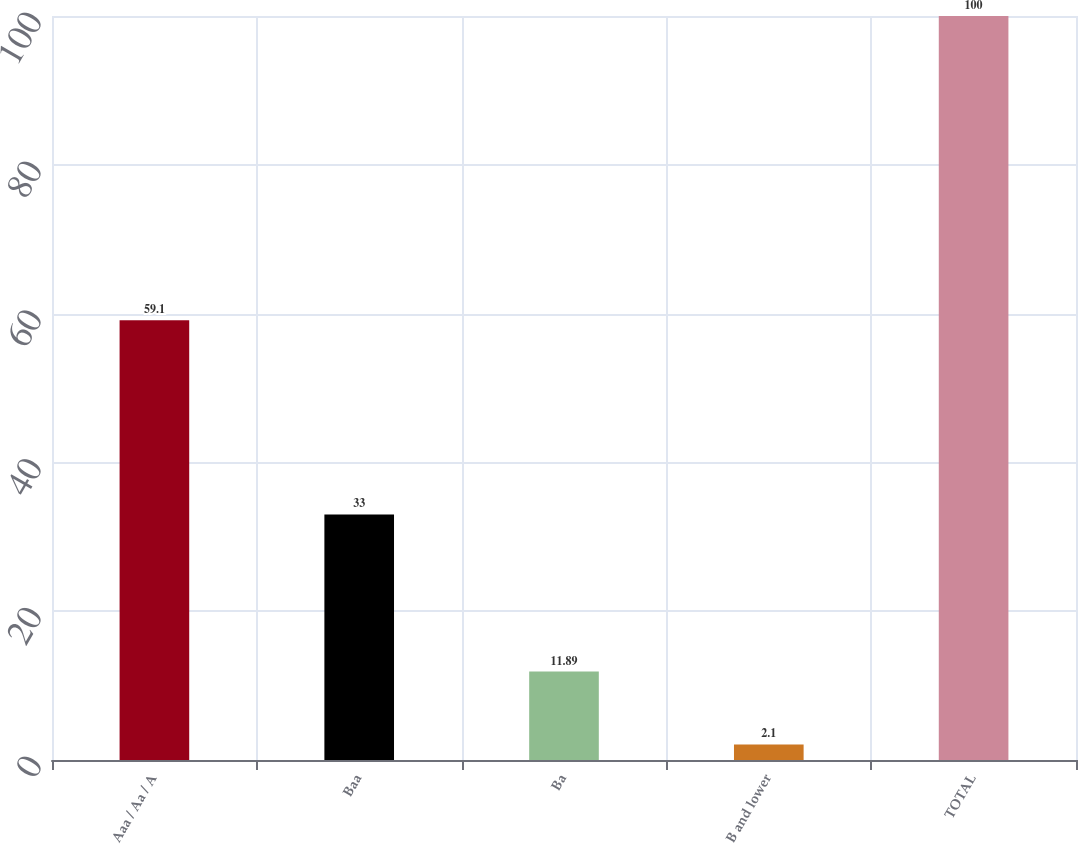<chart> <loc_0><loc_0><loc_500><loc_500><bar_chart><fcel>Aaa / Aa / A<fcel>Baa<fcel>Ba<fcel>B and lower<fcel>TOTAL<nl><fcel>59.1<fcel>33<fcel>11.89<fcel>2.1<fcel>100<nl></chart> 